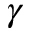Convert formula to latex. <formula><loc_0><loc_0><loc_500><loc_500>\gamma</formula> 